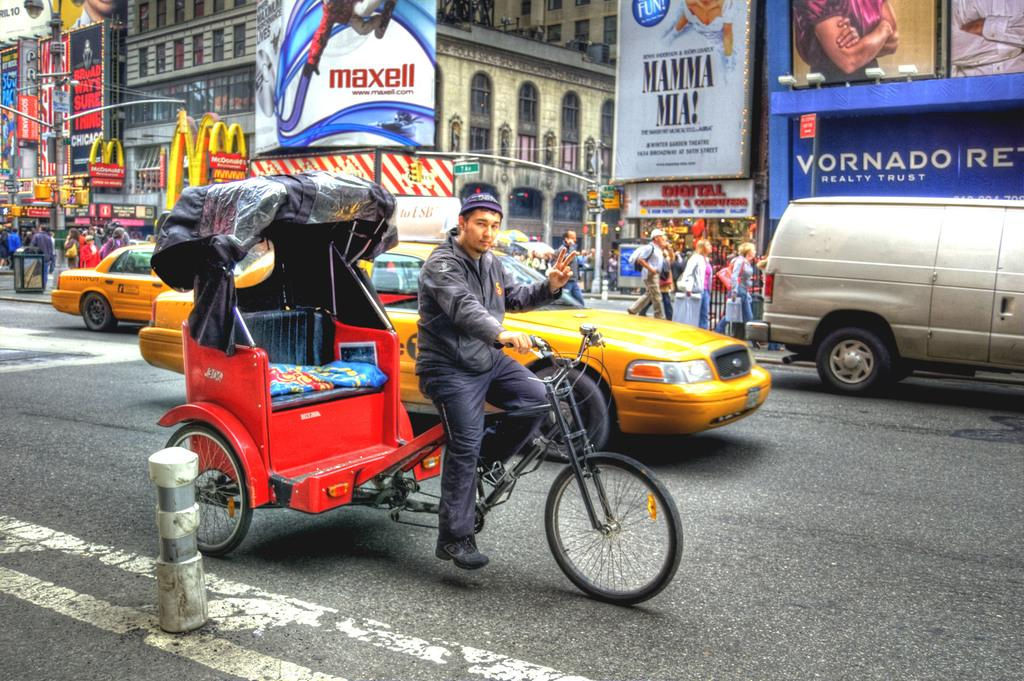<image>
Summarize the visual content of the image. A "McDonald's" sign hangs on the side of the building. 